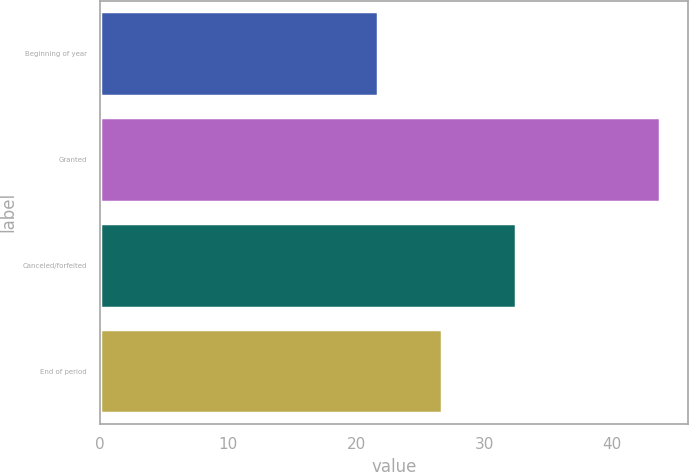<chart> <loc_0><loc_0><loc_500><loc_500><bar_chart><fcel>Beginning of year<fcel>Granted<fcel>Canceled/forfeited<fcel>End of period<nl><fcel>21.68<fcel>43.69<fcel>32.46<fcel>26.69<nl></chart> 